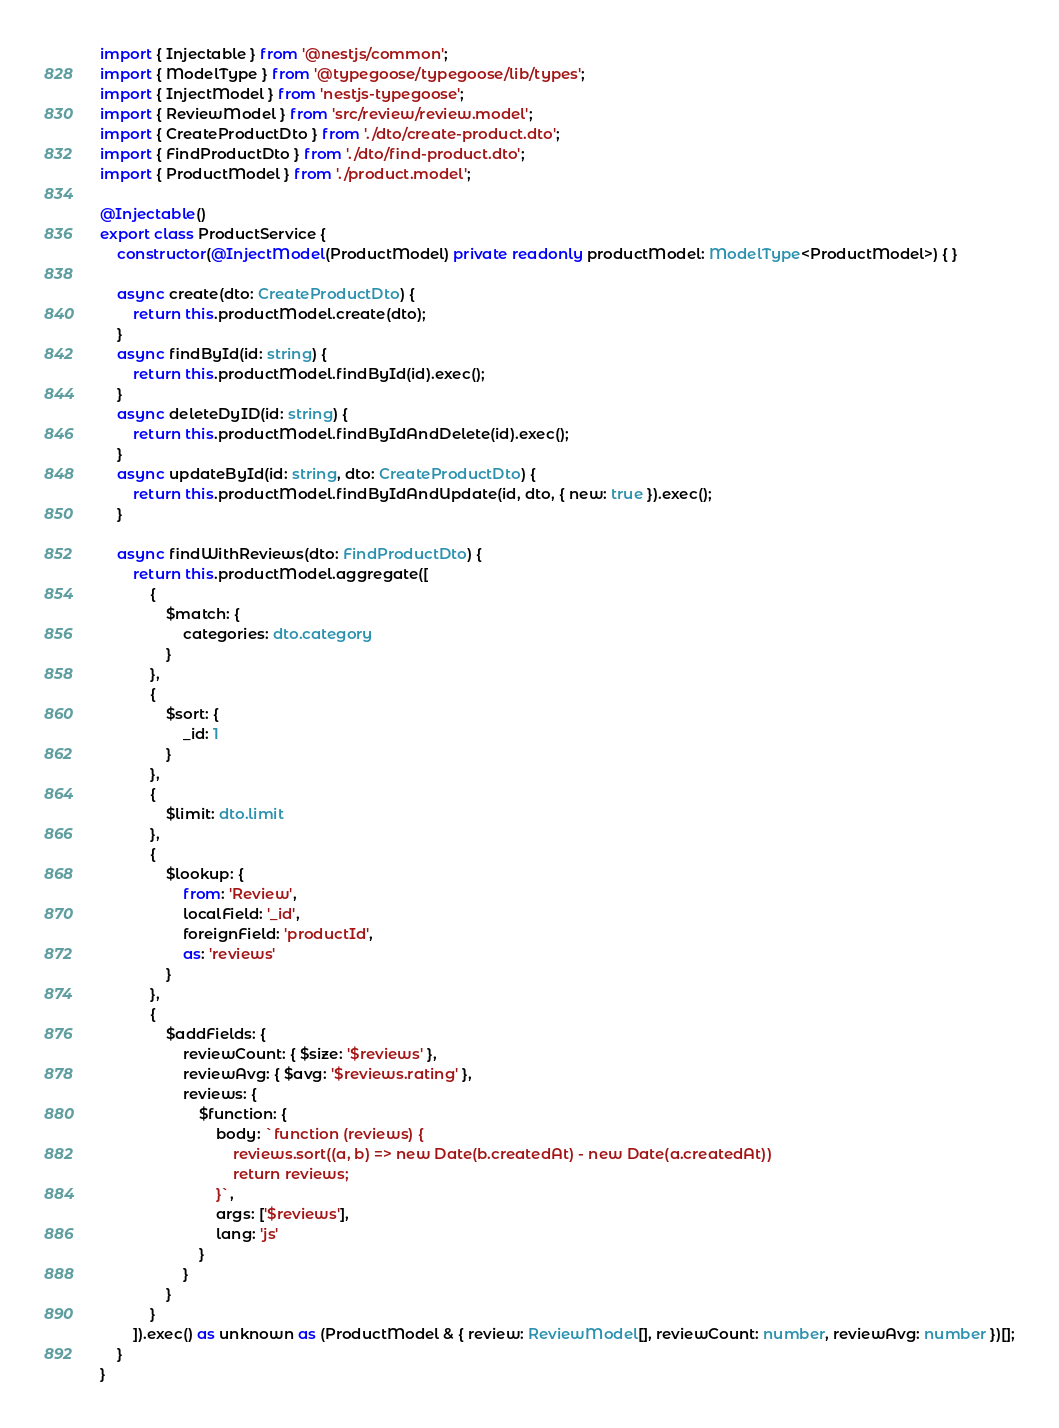Convert code to text. <code><loc_0><loc_0><loc_500><loc_500><_TypeScript_>import { Injectable } from '@nestjs/common';
import { ModelType } from '@typegoose/typegoose/lib/types';
import { InjectModel } from 'nestjs-typegoose';
import { ReviewModel } from 'src/review/review.model';
import { CreateProductDto } from './dto/create-product.dto';
import { FindProductDto } from './dto/find-product.dto';
import { ProductModel } from './product.model';

@Injectable()
export class ProductService {
	constructor(@InjectModel(ProductModel) private readonly productModel: ModelType<ProductModel>) { }

	async create(dto: CreateProductDto) {
		return this.productModel.create(dto);
	}
	async findById(id: string) {
		return this.productModel.findById(id).exec();
	}
	async deleteDyID(id: string) {
		return this.productModel.findByIdAndDelete(id).exec();
	}
	async updateById(id: string, dto: CreateProductDto) {
		return this.productModel.findByIdAndUpdate(id, dto, { new: true }).exec();
	}

	async findWithReviews(dto: FindProductDto) {
		return this.productModel.aggregate([
			{
				$match: {
					categories: dto.category
				}
			},
			{
				$sort: {
					_id: 1
				}
			},
			{
				$limit: dto.limit
			},
			{
				$lookup: {
					from: 'Review',
					localField: '_id',
					foreignField: 'productId',
					as: 'reviews'
				}
			},
			{
				$addFields: {
					reviewCount: { $size: '$reviews' },
					reviewAvg: { $avg: '$reviews.rating' },
					reviews: {
						$function: {
							body: `function (reviews) {
								reviews.sort((a, b) => new Date(b.createdAt) - new Date(a.createdAt))
								return reviews;
							}`,
							args: ['$reviews'],
							lang: 'js'
						}
					}
				}
			}
		]).exec() as unknown as (ProductModel & { review: ReviewModel[], reviewCount: number, reviewAvg: number })[];
	}
}
</code> 